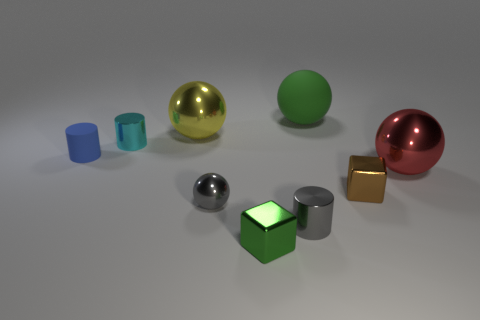Add 1 big purple shiny blocks. How many objects exist? 10 Subtract all shiny balls. How many balls are left? 1 Subtract all yellow balls. How many balls are left? 3 Subtract all cubes. How many objects are left? 7 Subtract all cyan spheres. Subtract all blue cubes. How many spheres are left? 4 Subtract all green metallic blocks. Subtract all small cyan cubes. How many objects are left? 8 Add 1 red objects. How many red objects are left? 2 Add 6 balls. How many balls exist? 10 Subtract 0 blue balls. How many objects are left? 9 